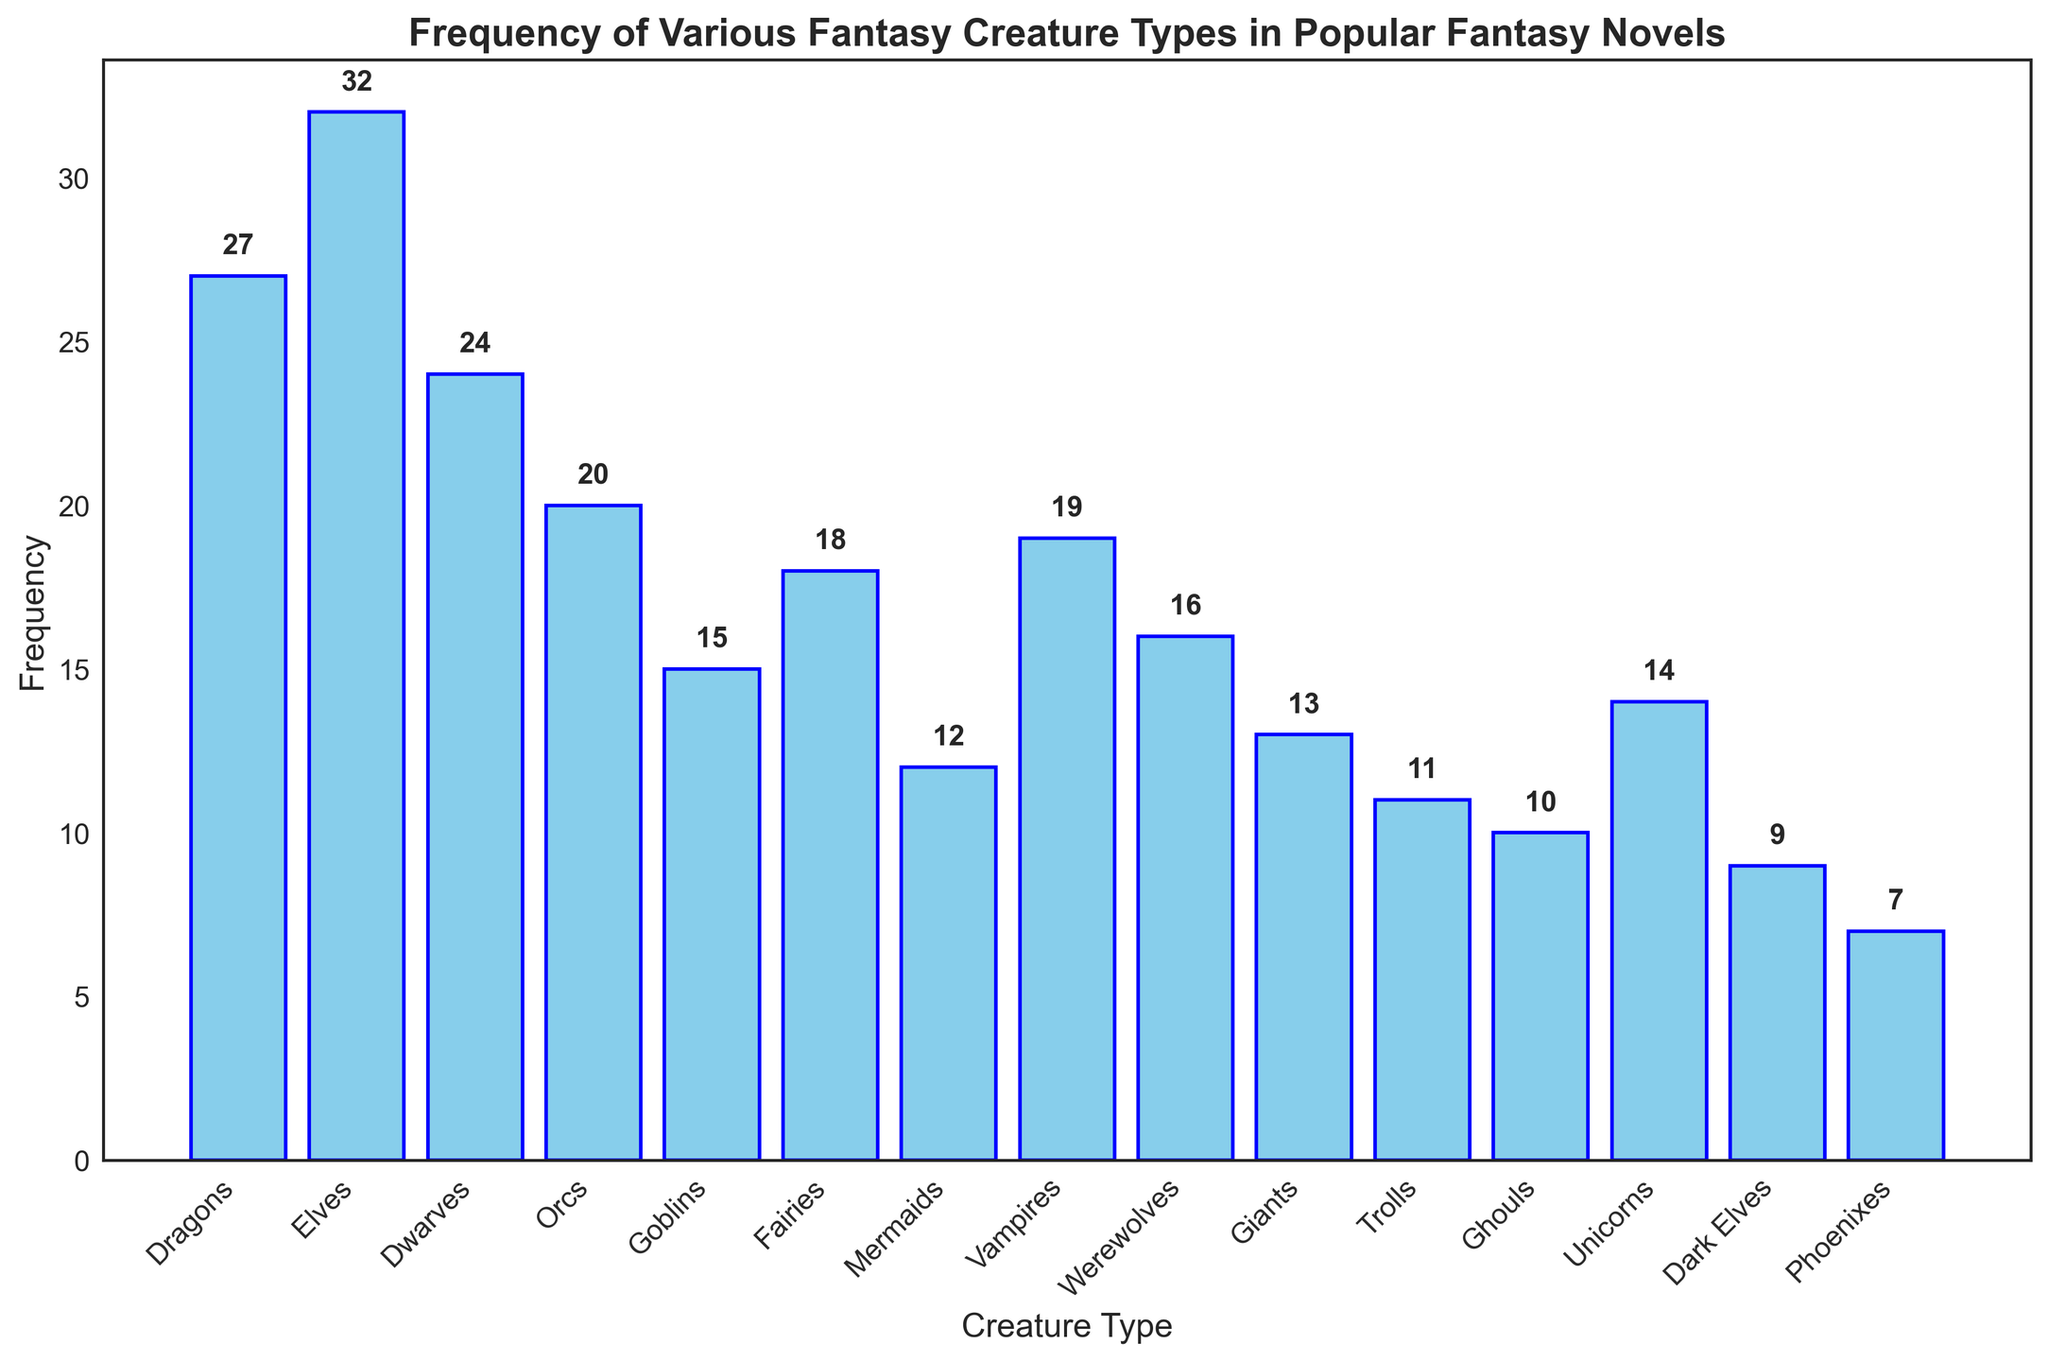What is the frequency of Dragons in the chart? The bar labeled "Dragons" has a height which indicates the frequency. By looking at the number above the bar, it's 27.
Answer: 27 Which creature type has the highest frequency? By scanning all the bars, the one labeled "Elves" has the highest bar, indicating the highest frequency at 32.
Answer: Elves How many creature types have a frequency greater than 20? The creature types with frequencies above 20 are "Dragons" (27), "Elves" (32), and "Dwarves" (24), totaling three creature types.
Answer: 3 What is the combined frequency of Dragons, Elves, and Dwarves? Adding the frequencies of "Dragons" (27), "Elves" (32), and "Dwarves" (24): 27 + 32 + 24 = 83.
Answer: 83 Is the frequency of Orcs higher than that of Goblins? The frequency of Orcs is 20 and for Goblins, it's 15. Since 20 is greater than 15, the frequency of Orcs is higher.
Answer: Yes Which creature type has the lowest frequency and what is it? Among all bars, the bar labeled "Phoenixes" is the shortest, indicating the lowest frequency at 7.
Answer: Phoenixes How many creature types have a frequency between 10 and 20 inclusive? The creature types with frequencies in the range 10-20 are "Goblins" (15), "Fairies" (18), "Mermaids" (12), "Vampires" (19), "Werewolves" (16), "Giants" (13), "Trolls" (11), and "Unicorns" (14). Counting these gives 8.
Answer: 8 Compare the frequency of Vampires to that of Werewolves. Are they equal? The frequency of Vampires is 19 and that of Werewolves is 16. Since 19 is not equal to 16, they are not equal.
Answer: No What is the average frequency of all creature types? Adding up all the frequencies: 27 + 32 + 24 + 20 + 15 + 18 + 12 + 19 + 16 + 13 + 11 + 10 + 14 + 9 + 7 = 247. Dividing by the number of types, which is 15: 247 / 15 ≈ 16.47.
Answer: 16.47 Is the frequency of Phoenixes less than that of Dark Elves? The frequency of Phoenixes is 7 and for Dark Elves, it's 9. Since 7 is less than 9, the frequency of Phoenixes is indeed less.
Answer: Yes 